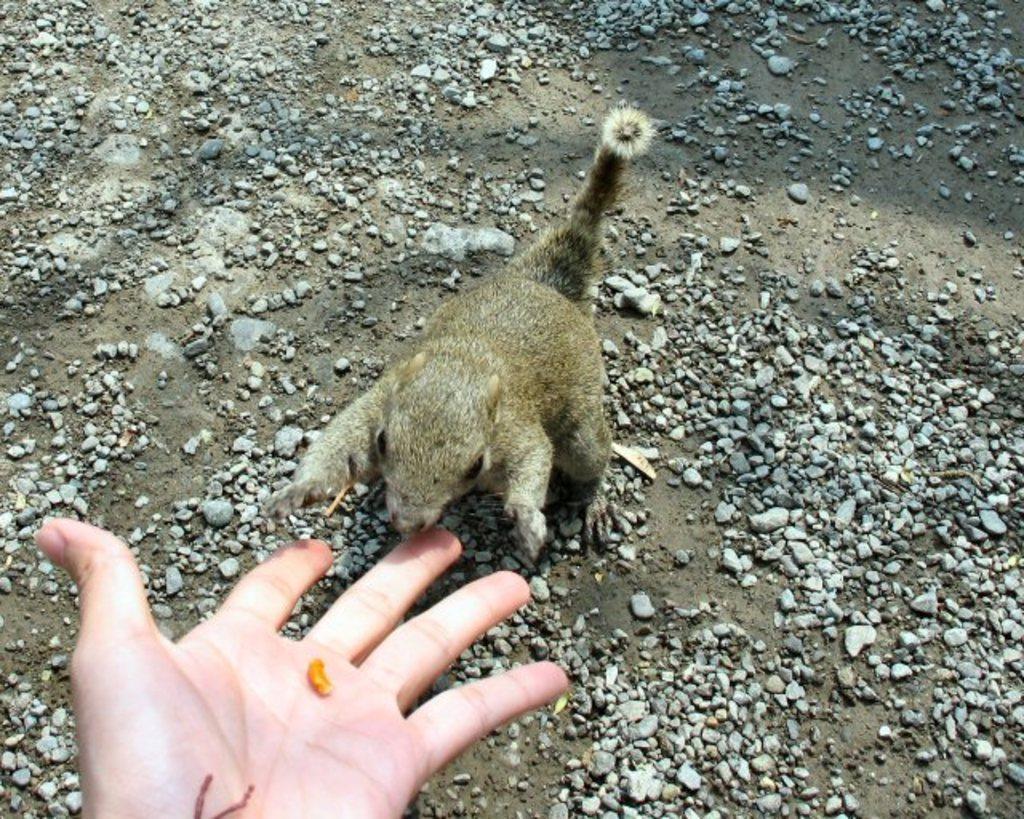How would you summarize this image in a sentence or two? This picture a squirrel and we see a human hand and we see a nut in the hand and we see small stones on the ground. 